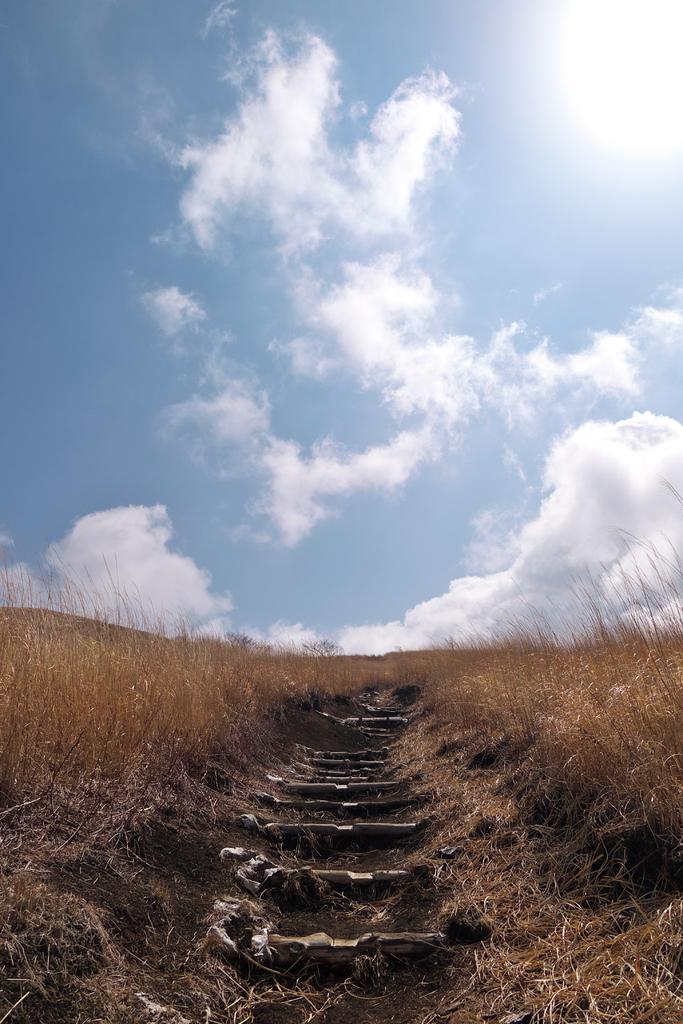What type of vegetation can be seen on the ground in the image? There is dried grass on the ground in the image. What architectural feature is present in the image? There are steps in the center of the image. What is visible at the top of the image? The sky is visible at the top of the image. What type of rice is being cooked by the army in the image? There is no rice or army present in the image. What type of expansion is visible in the image? There is no expansion visible in the image; it features dried grass, steps, and the sky. 